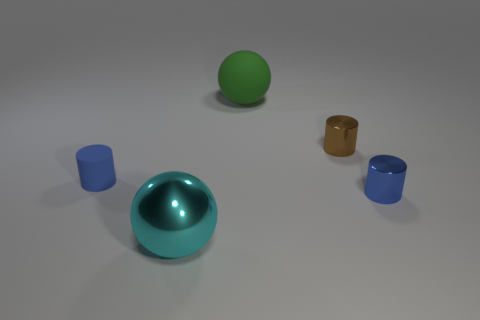There is a small blue cylinder on the right side of the tiny blue matte cylinder; what is its material?
Your answer should be very brief. Metal. Is the shape of the object that is in front of the blue shiny thing the same as the metallic thing that is behind the tiny blue matte cylinder?
Ensure brevity in your answer.  No. Are there an equal number of balls that are behind the cyan shiny sphere and red spheres?
Your answer should be compact. No. What number of large purple things have the same material as the large cyan object?
Offer a terse response. 0. There is another object that is made of the same material as the big green object; what color is it?
Make the answer very short. Blue. There is a blue matte cylinder; is it the same size as the blue thing to the right of the large green object?
Make the answer very short. Yes. What shape is the tiny matte thing?
Provide a succinct answer. Cylinder. How many spheres are the same color as the tiny matte object?
Keep it short and to the point. 0. There is a large metallic object that is the same shape as the green rubber thing; what is its color?
Your response must be concise. Cyan. What number of large metal balls are right of the matte thing that is in front of the big green object?
Your answer should be compact. 1. 